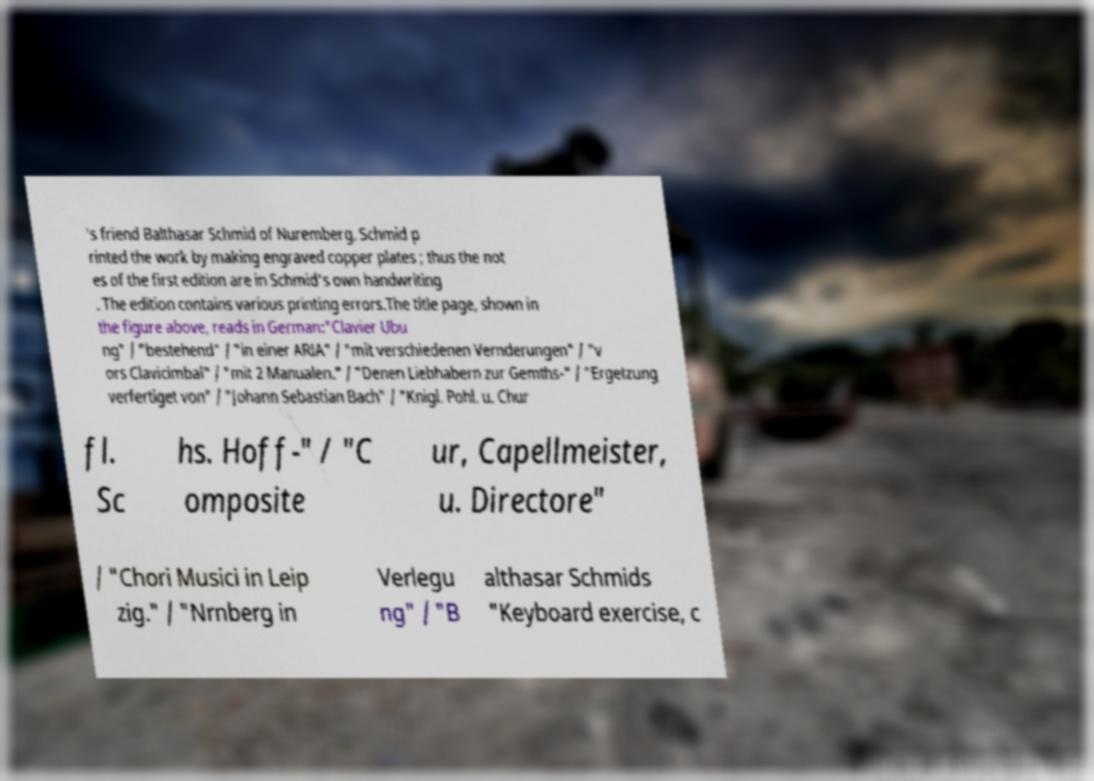For documentation purposes, I need the text within this image transcribed. Could you provide that? 's friend Balthasar Schmid of Nuremberg. Schmid p rinted the work by making engraved copper plates ; thus the not es of the first edition are in Schmid's own handwriting . The edition contains various printing errors.The title page, shown in the figure above, reads in German:"Clavier Ubu ng" / "bestehend" / "in einer ARIA" / "mit verschiedenen Vernderungen" / "v ors Clavicimbal" / "mit 2 Manualen." / "Denen Liebhabern zur Gemths-" / "Ergetzung verfertiget von" / "Johann Sebastian Bach" / "Knigl. Pohl. u. Chur fl. Sc hs. Hoff-" / "C omposite ur, Capellmeister, u. Directore" / "Chori Musici in Leip zig." / "Nrnberg in Verlegu ng" / "B althasar Schmids "Keyboard exercise, c 